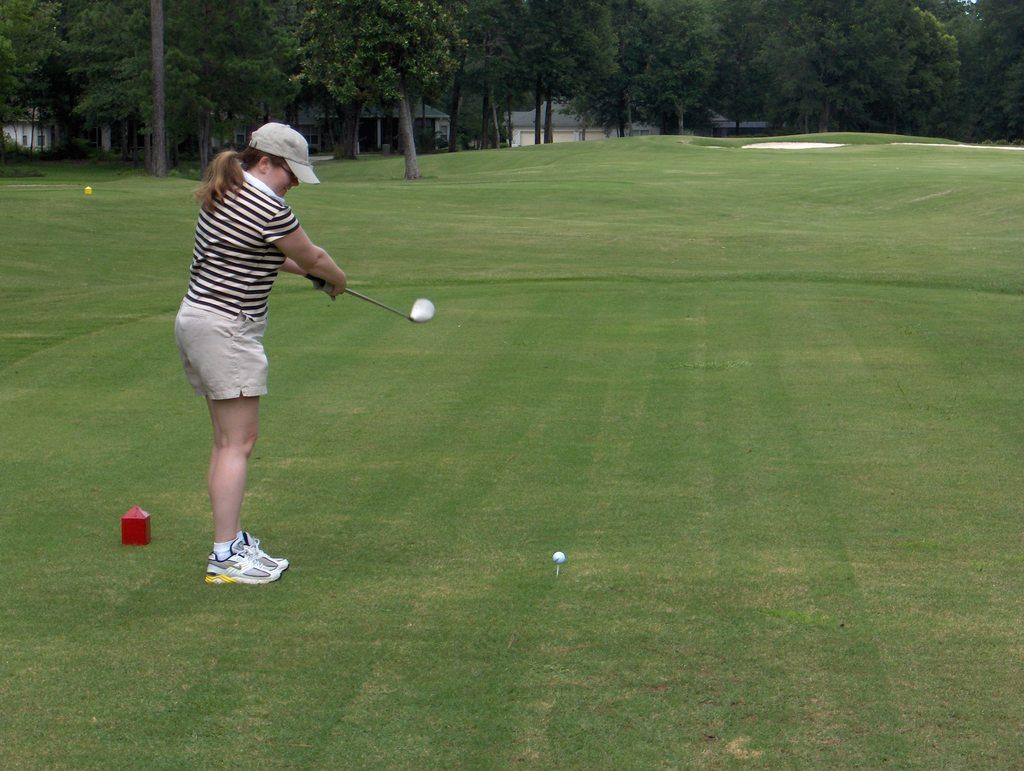Could you give a brief overview of what you see in this image? In this picture I can see there is a woman standing and holding a hockey bat and there is a ball here on the grass and in the backdrop I can see there are trees. 